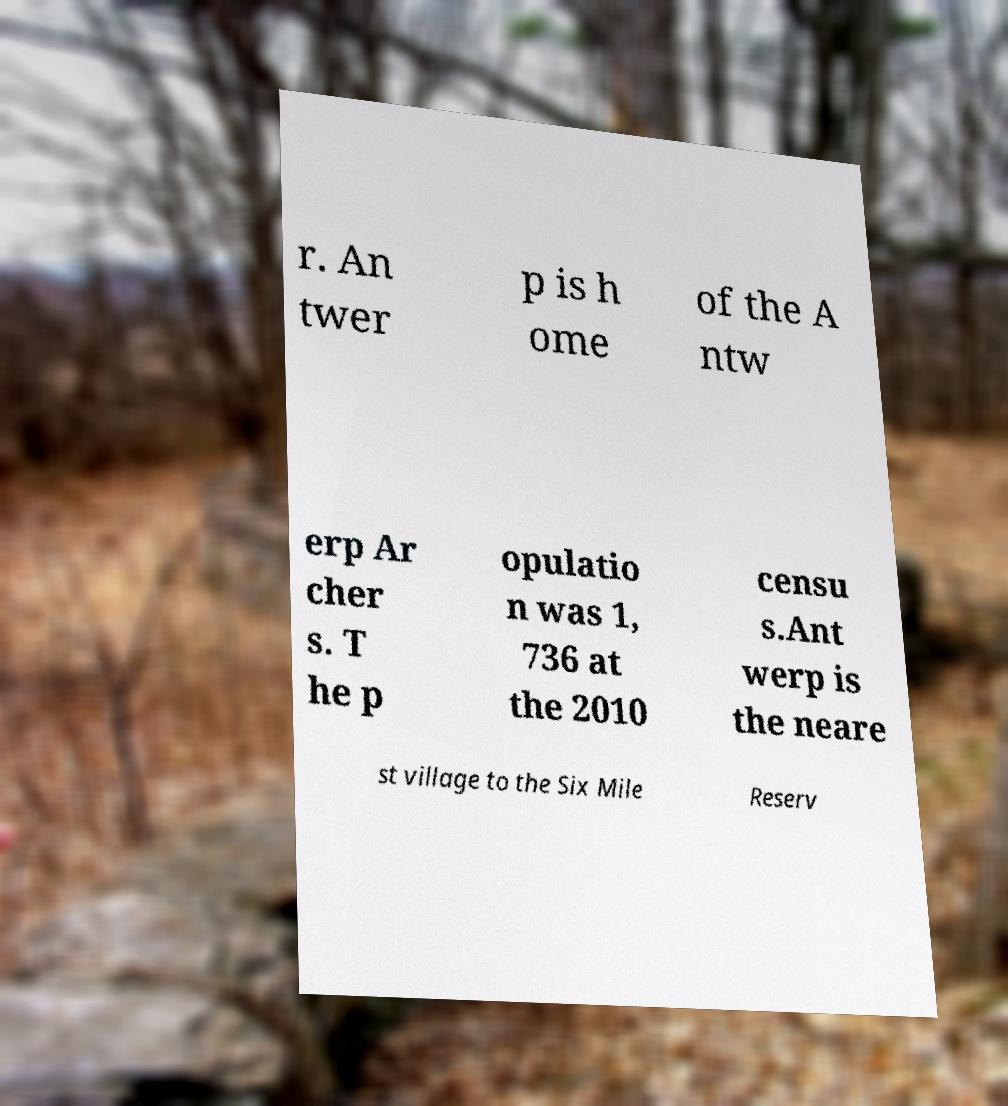There's text embedded in this image that I need extracted. Can you transcribe it verbatim? r. An twer p is h ome of the A ntw erp Ar cher s. T he p opulatio n was 1, 736 at the 2010 censu s.Ant werp is the neare st village to the Six Mile Reserv 